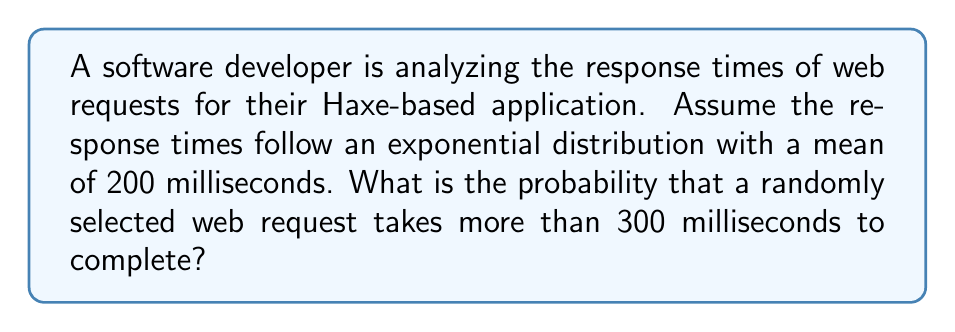Solve this math problem. Let's approach this step-by-step:

1) The exponential distribution is often used to model the time between events in a Poisson process, which is suitable for modeling web request response times.

2) The probability density function of an exponential distribution is:

   $$f(x) = \lambda e^{-\lambda x}$$

   where $\lambda$ is the rate parameter.

3) We're given that the mean is 200 ms. For an exponential distribution, the mean is equal to $\frac{1}{\lambda}$. So:

   $$\frac{1}{\lambda} = 200$$
   $$\lambda = \frac{1}{200} = 0.005$$

4) We want to find $P(X > 300)$, where $X$ is the response time.

5) For an exponential distribution:

   $$P(X > x) = e^{-\lambda x}$$

6) Substituting our values:

   $$P(X > 300) = e^{-0.005 * 300}$$

7) Calculating:

   $$P(X > 300) = e^{-1.5} \approx 0.2231$$

Thus, the probability is approximately 0.2231 or about 22.31%.
Answer: $e^{-1.5} \approx 0.2231$ 